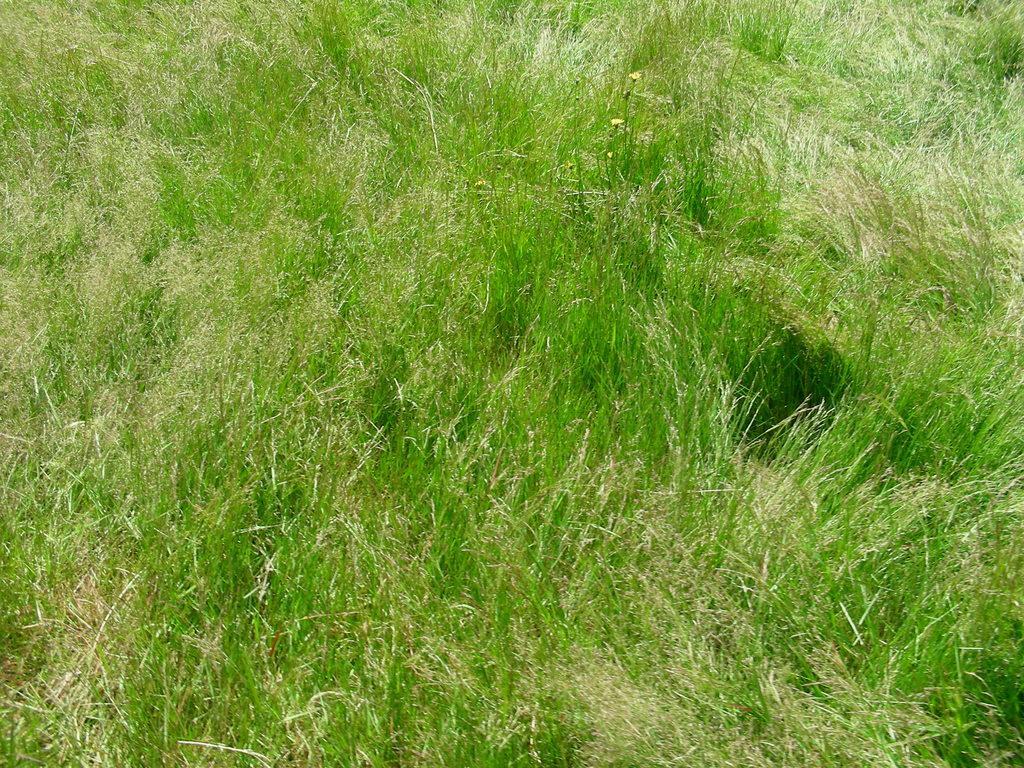In one or two sentences, can you explain what this image depicts? In this picture I can see grass. 